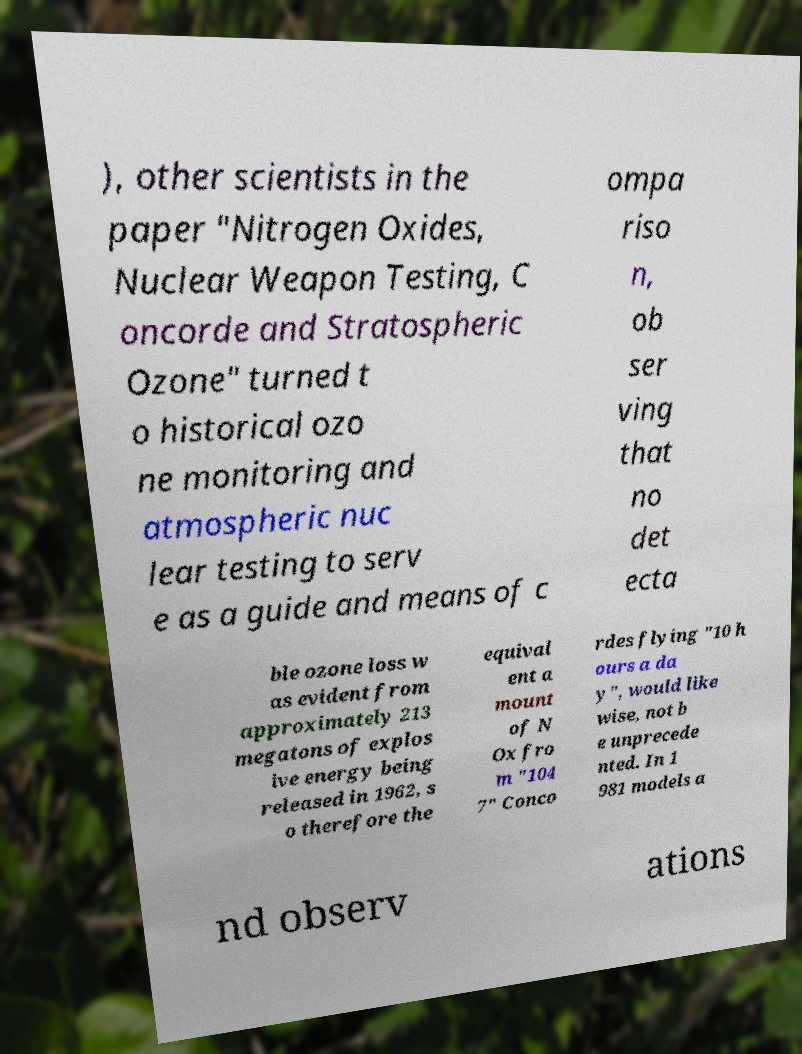Please read and relay the text visible in this image. What does it say? ), other scientists in the paper "Nitrogen Oxides, Nuclear Weapon Testing, C oncorde and Stratospheric Ozone" turned t o historical ozo ne monitoring and atmospheric nuc lear testing to serv e as a guide and means of c ompa riso n, ob ser ving that no det ecta ble ozone loss w as evident from approximately 213 megatons of explos ive energy being released in 1962, s o therefore the equival ent a mount of N Ox fro m "104 7" Conco rdes flying "10 h ours a da y", would like wise, not b e unprecede nted. In 1 981 models a nd observ ations 